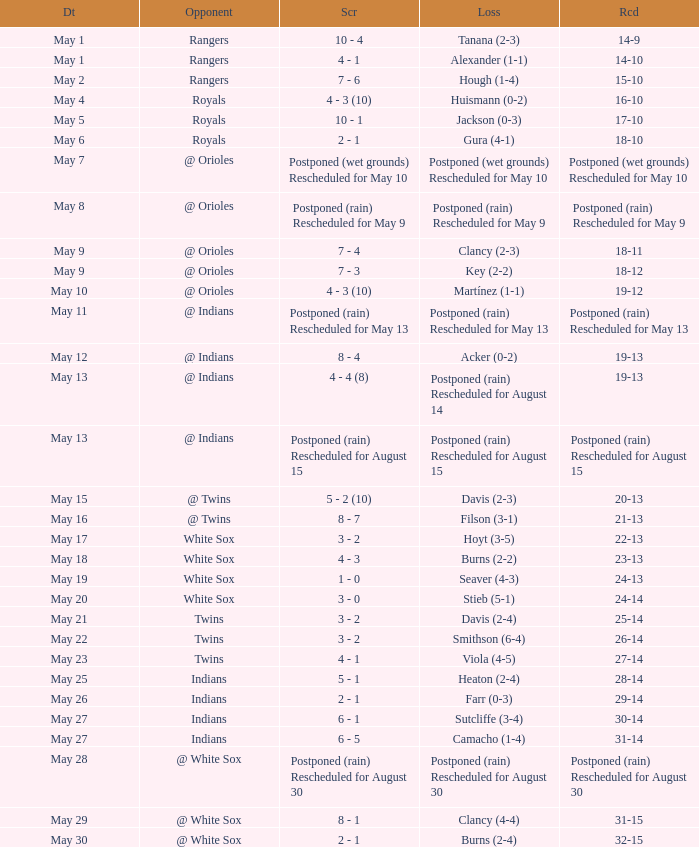When the score was 21-13, what was the game's loss? Filson (3-1). 